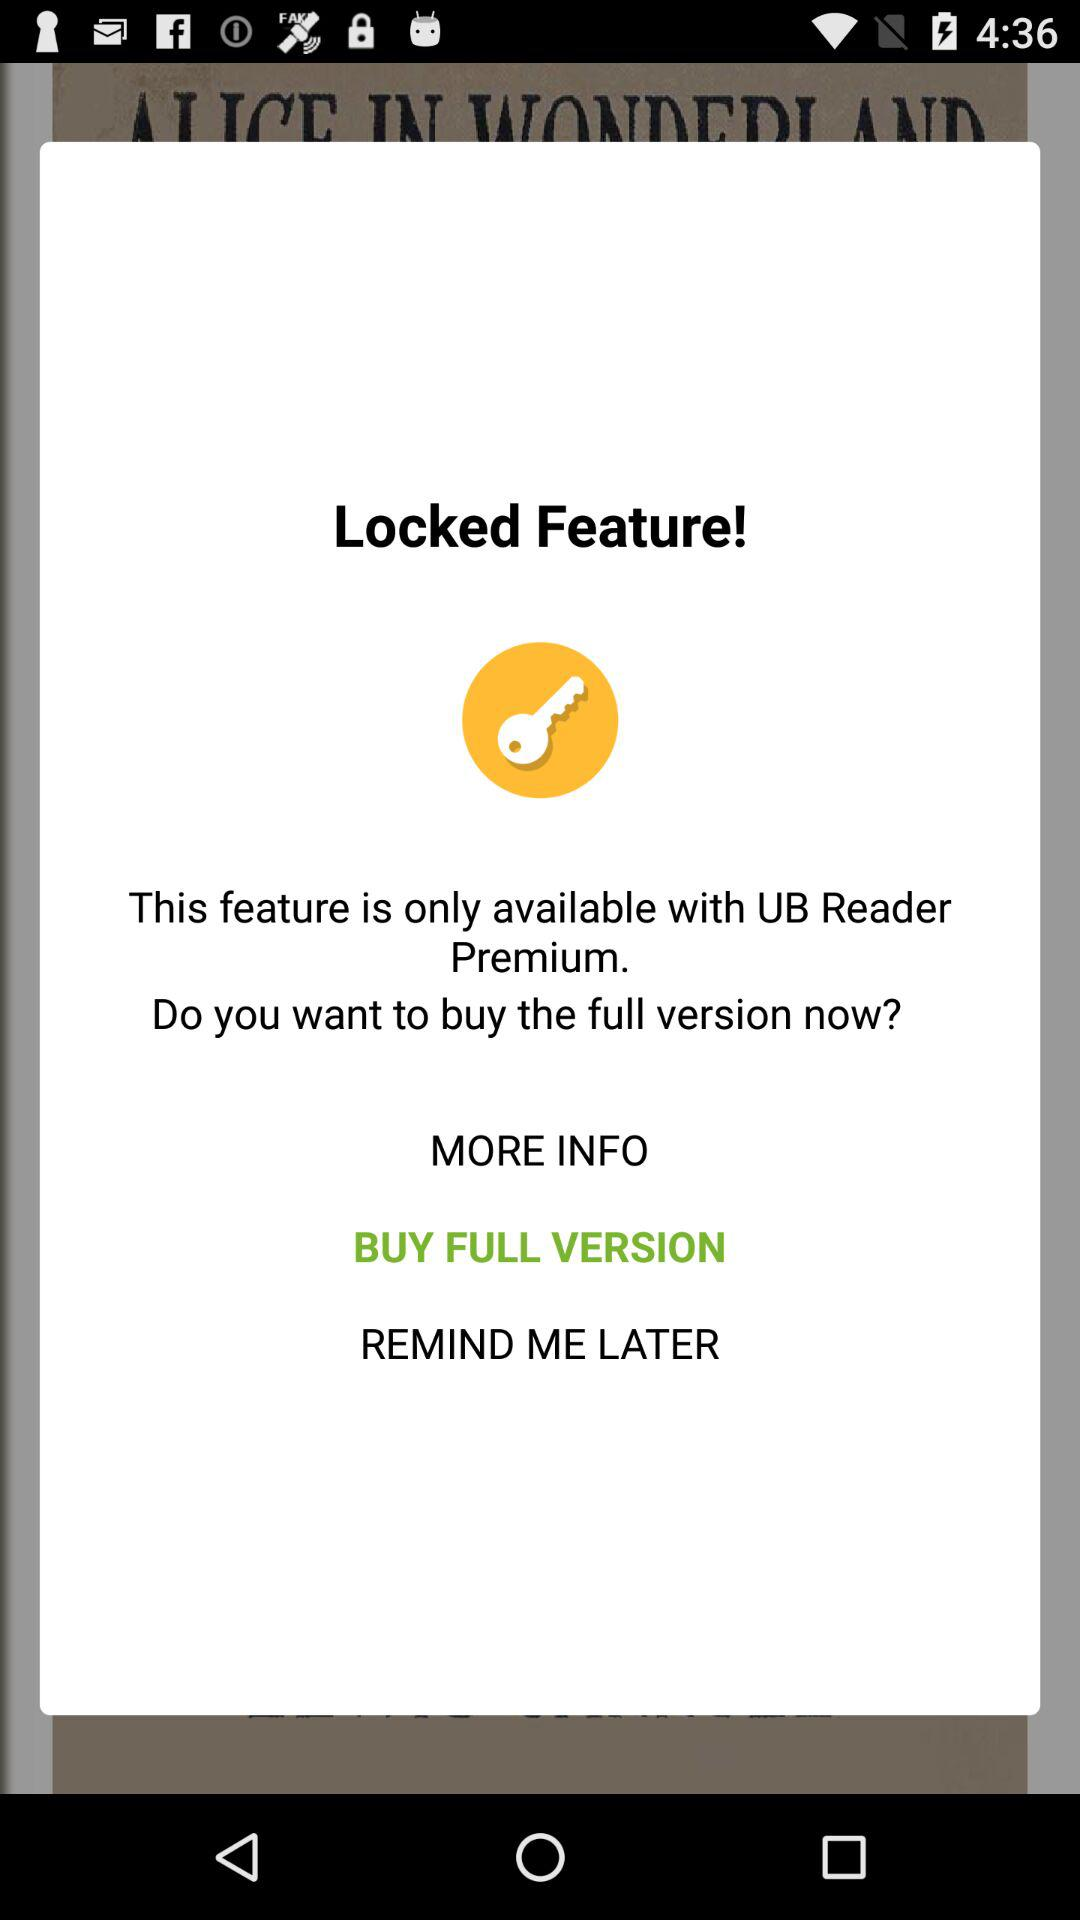"Locked Feature" is available with what application? The Locked Feature is available with the "UB Reader Premium" application. 